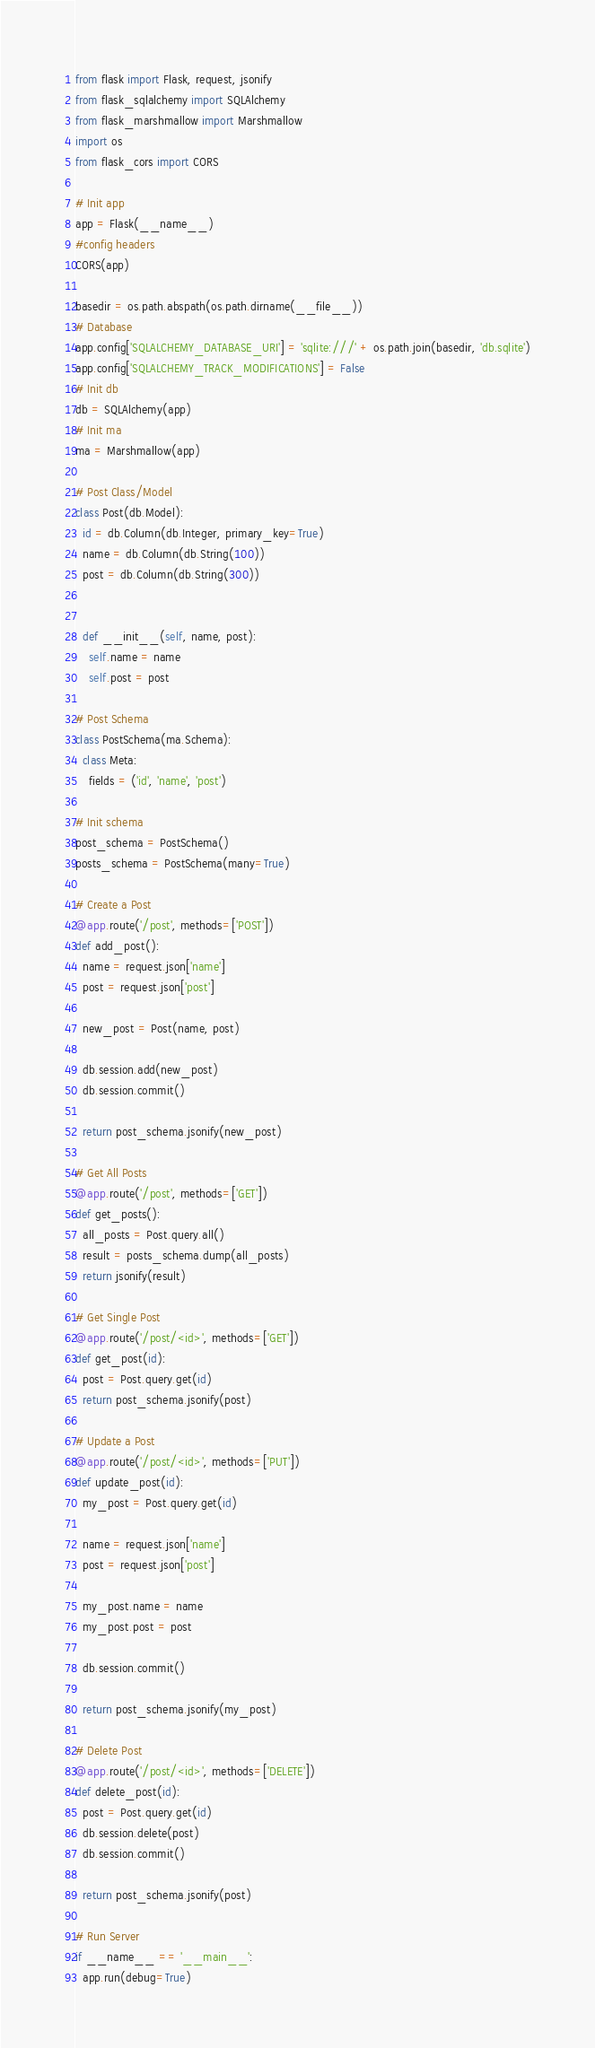<code> <loc_0><loc_0><loc_500><loc_500><_Python_>from flask import Flask, request, jsonify
from flask_sqlalchemy import SQLAlchemy 
from flask_marshmallow import Marshmallow 
import os
from flask_cors import CORS

# Init app
app = Flask(__name__)
#config headers
CORS(app)

basedir = os.path.abspath(os.path.dirname(__file__))
# Database
app.config['SQLALCHEMY_DATABASE_URI'] = 'sqlite:///' + os.path.join(basedir, 'db.sqlite')
app.config['SQLALCHEMY_TRACK_MODIFICATIONS'] = False
# Init db
db = SQLAlchemy(app)
# Init ma
ma = Marshmallow(app)

# Post Class/Model
class Post(db.Model):
  id = db.Column(db.Integer, primary_key=True)
  name = db.Column(db.String(100))
  post = db.Column(db.String(300))
  

  def __init__(self, name, post):
    self.name = name
    self.post = post

# Post Schema
class PostSchema(ma.Schema):
  class Meta:
    fields = ('id', 'name', 'post')

# Init schema
post_schema = PostSchema()
posts_schema = PostSchema(many=True)

# Create a Post
@app.route('/post', methods=['POST'])
def add_post():
  name = request.json['name']
  post = request.json['post']

  new_post = Post(name, post)

  db.session.add(new_post)
  db.session.commit()

  return post_schema.jsonify(new_post)

# Get All Posts
@app.route('/post', methods=['GET'])
def get_posts():
  all_posts = Post.query.all()
  result = posts_schema.dump(all_posts)
  return jsonify(result)

# Get Single Post
@app.route('/post/<id>', methods=['GET'])
def get_post(id):
  post = Post.query.get(id)
  return post_schema.jsonify(post)

# Update a Post
@app.route('/post/<id>', methods=['PUT'])
def update_post(id):
  my_post = Post.query.get(id)

  name = request.json['name']
  post = request.json['post']

  my_post.name = name
  my_post.post = post

  db.session.commit()

  return post_schema.jsonify(my_post)

# Delete Post
@app.route('/post/<id>', methods=['DELETE'])
def delete_post(id):
  post = Post.query.get(id)
  db.session.delete(post)
  db.session.commit()

  return post_schema.jsonify(post)

# Run Server
if __name__ == '__main__':
  app.run(debug=True)</code> 